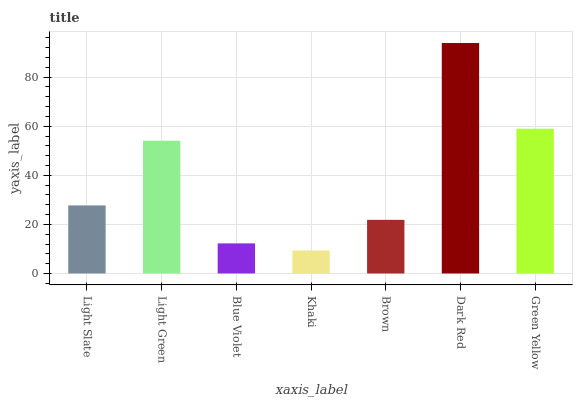Is Khaki the minimum?
Answer yes or no. Yes. Is Dark Red the maximum?
Answer yes or no. Yes. Is Light Green the minimum?
Answer yes or no. No. Is Light Green the maximum?
Answer yes or no. No. Is Light Green greater than Light Slate?
Answer yes or no. Yes. Is Light Slate less than Light Green?
Answer yes or no. Yes. Is Light Slate greater than Light Green?
Answer yes or no. No. Is Light Green less than Light Slate?
Answer yes or no. No. Is Light Slate the high median?
Answer yes or no. Yes. Is Light Slate the low median?
Answer yes or no. Yes. Is Light Green the high median?
Answer yes or no. No. Is Light Green the low median?
Answer yes or no. No. 